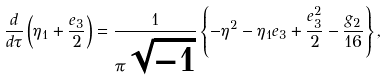<formula> <loc_0><loc_0><loc_500><loc_500>\frac { d } { d \tau } \left ( \eta _ { 1 } + \frac { e _ { 3 } } { 2 } \right ) = \frac { 1 } { \pi \sqrt { - 1 } } \left \{ - \eta ^ { 2 } - \eta _ { 1 } e _ { 3 } + \frac { e _ { 3 } ^ { 2 } } { 2 } - \frac { g _ { 2 } } { 1 6 } \right \} ,</formula> 